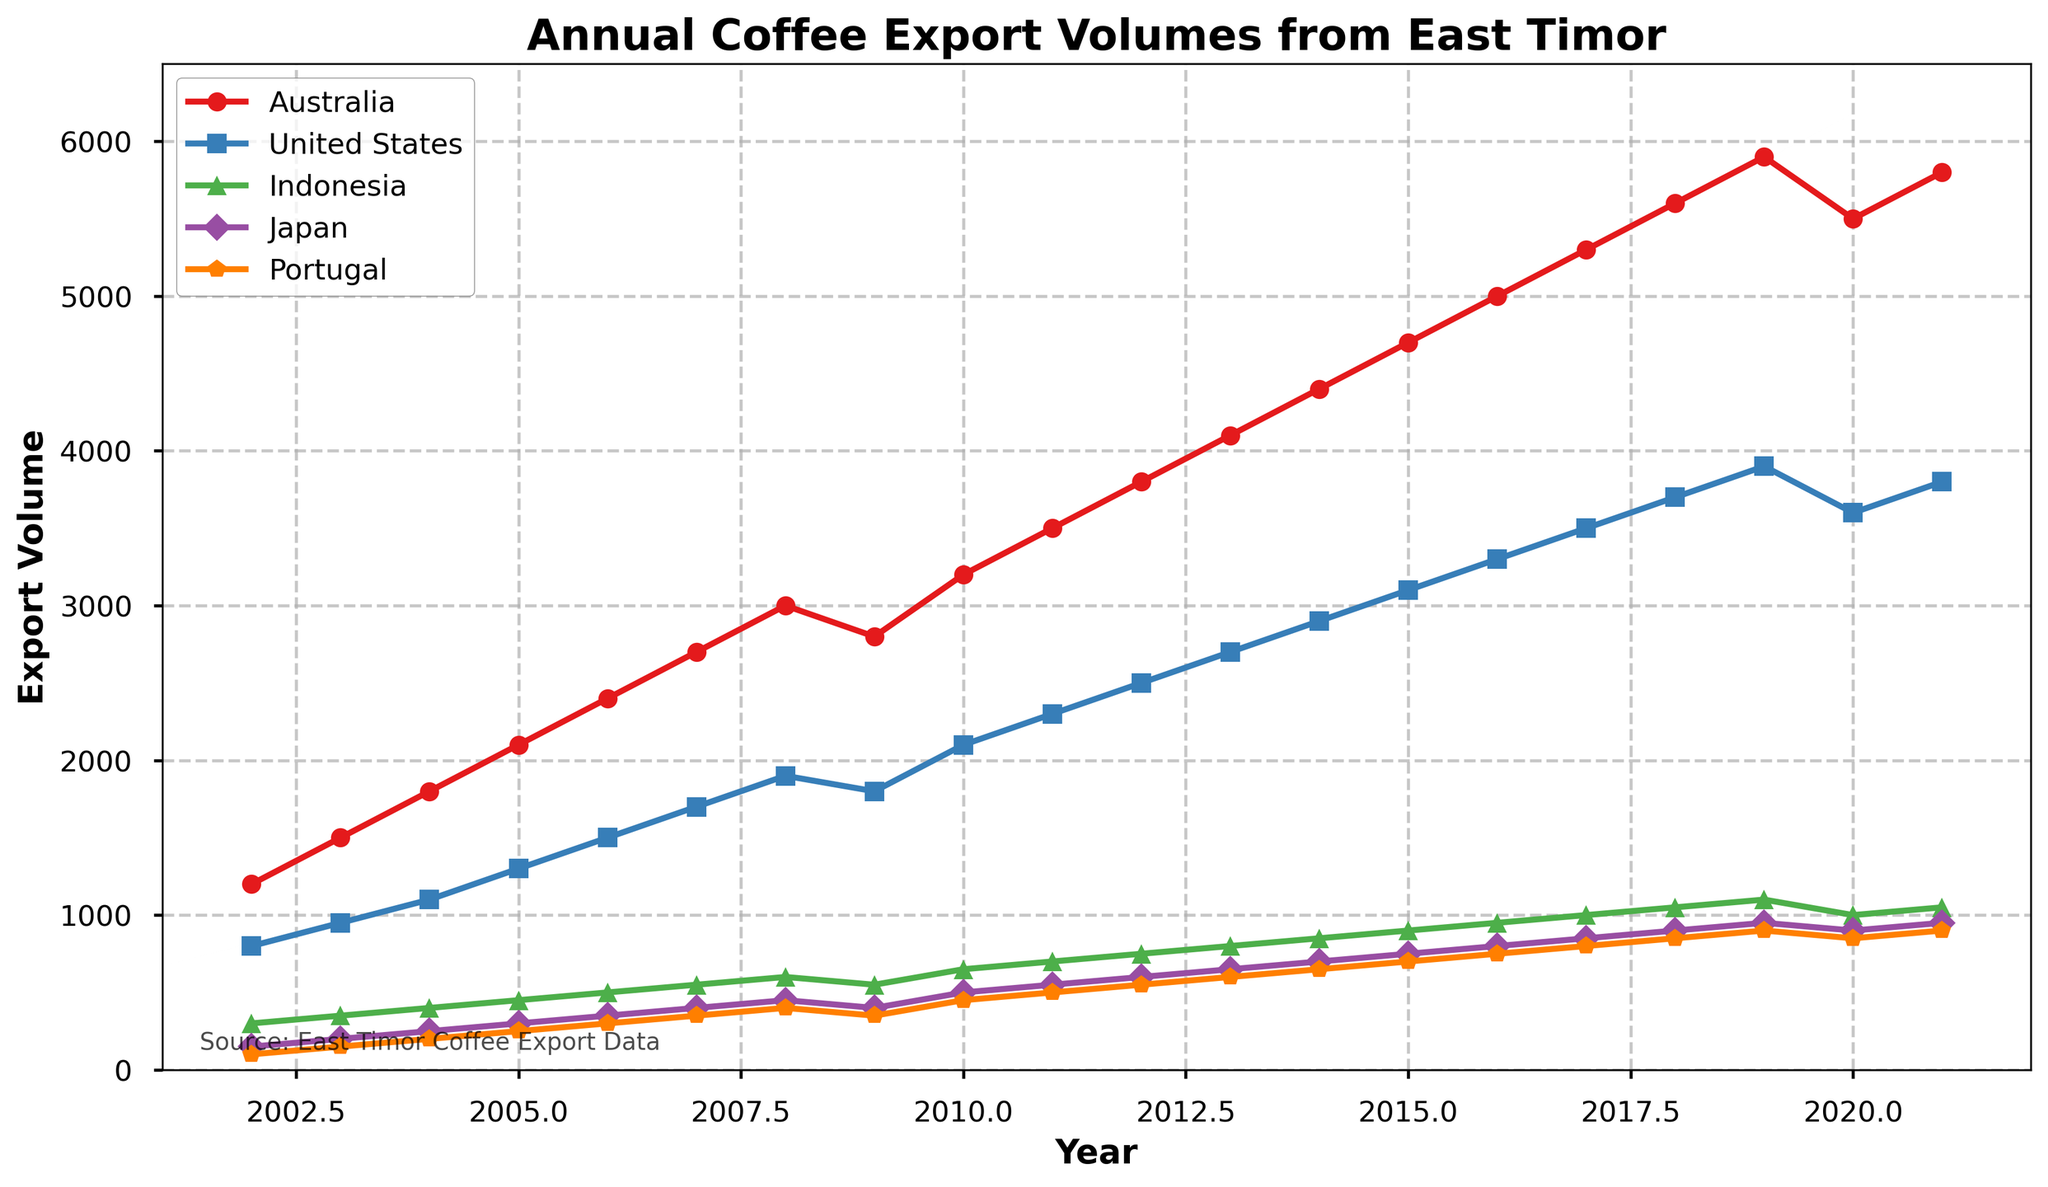What was the export volume to the United States in 2020? Look for the point where the curve for the United States intersects with the year 2020 on the x-axis. From the plot, it shows the volume is 3600.
Answer: 3600 Which country experienced the highest increase in coffee export volume in 2006? Compare the slopes of the lines for each country from 2005 to 2006. The country with the steepest upward slope represents the highest increase. The plot shows that all countries seem to have increasing trends but 'Australia' shows the most significant jump.
Answer: Australia What is the average coffee export volume to Japan from 2010 to 2012? Locate the points on Japan's line corresponding to the years 2010, 2011, and 2012. Add the volumes for these years (500, 550, 600) and divide by 3. Calculated: (500 + 550 + 600) / 3 = 550.
Answer: 550 Which country had the least variation in export volumes over the years shown? Examine the lines' smoothness and any sharp changes. 'Indonesia' shows the least variation as its line is the flattest among all the countries.
Answer: Indonesia In what year did Portugal's coffee export volume exceed 700? Trace Portugal's line and determine the year when the line crosses the 700 mark on the y-axis. It happens in 2017.
Answer: 2017 Which two countries had the most similar export volumes in 2013? Compare the points on the plot for each country in 2013. The lines for Portugal and Japan are closest, indicating similar volumes.
Answer: Portugal and Japan By how much did Australia's export volume in 2009 decrease from 2008? Identify the volumes for Australia in 2008 and 2009 and calculate the difference. From the plot: 3000(2008) - 2800(2009) = 200.
Answer: 200 Which country had a decline in export volume from 2019 to 2020? Look for a downward slope between 2019 and 2020. 'Australia's line shows a decline during this period.
Answer: Australia What was the total export volume to all countries in 2005? Sum the export volumes for all countries in 2005. From the plot: 2100 + 1300 + 450 + 300 + 250 = 4400.
Answer: 4400 Between 2019 and 2021, which country showed the most fluctuating pattern in export volume? Identify the country with the most visible ups and downs between 2019 and 2021. The plot shows 'Australia' has the most fluctuations.
Answer: Australia 